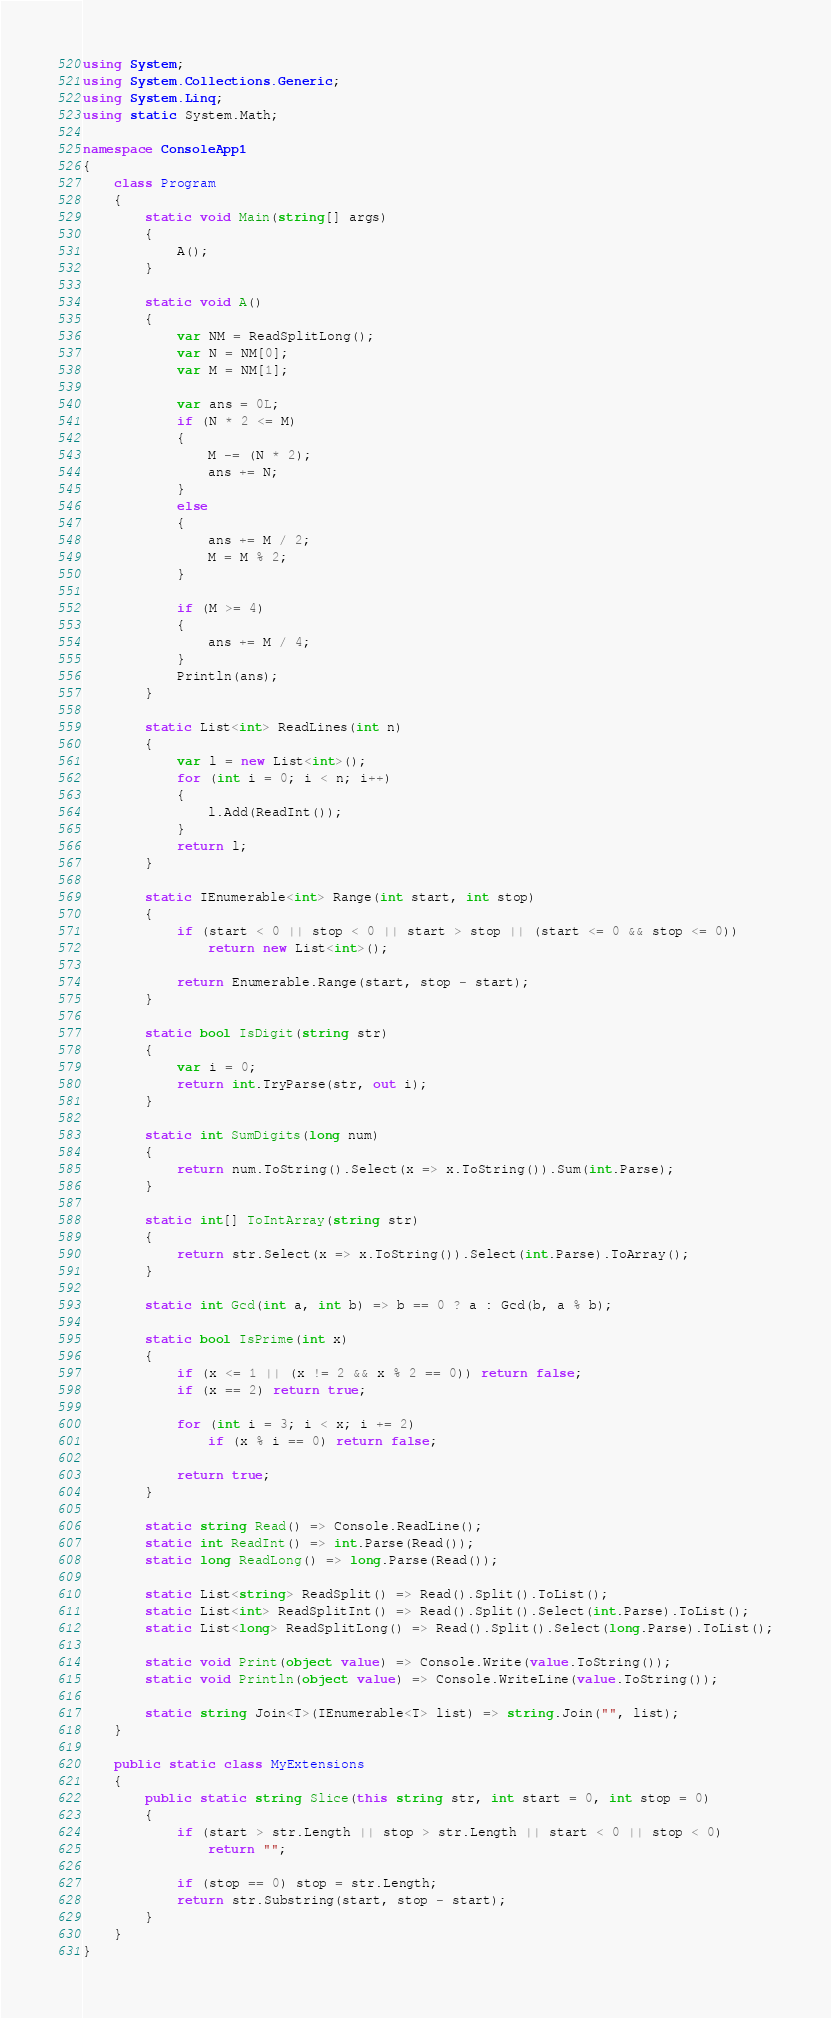Convert code to text. <code><loc_0><loc_0><loc_500><loc_500><_C#_>using System;
using System.Collections.Generic;
using System.Linq;
using static System.Math;

namespace ConsoleApp1
{
    class Program
    {
        static void Main(string[] args)
        {
            A();
        }

        static void A()
        {
            var NM = ReadSplitLong();
            var N = NM[0];
            var M = NM[1];

            var ans = 0L;
            if (N * 2 <= M)
            {
                M -= (N * 2);
                ans += N;
            }
            else
            {
                ans += M / 2;
                M = M % 2;
            }

            if (M >= 4)
            {
                ans += M / 4;
            }
            Println(ans);
        }

        static List<int> ReadLines(int n)
        {
            var l = new List<int>();
            for (int i = 0; i < n; i++)
            {
                l.Add(ReadInt());
            }
            return l;
        }

        static IEnumerable<int> Range(int start, int stop)
        {
            if (start < 0 || stop < 0 || start > stop || (start <= 0 && stop <= 0))
                return new List<int>();

            return Enumerable.Range(start, stop - start);
        }

        static bool IsDigit(string str)
        {
            var i = 0;
            return int.TryParse(str, out i);
        }

        static int SumDigits(long num)
        {
            return num.ToString().Select(x => x.ToString()).Sum(int.Parse);
        }

        static int[] ToIntArray(string str)
        {
            return str.Select(x => x.ToString()).Select(int.Parse).ToArray();
        }

        static int Gcd(int a, int b) => b == 0 ? a : Gcd(b, a % b);

        static bool IsPrime(int x)
        {
            if (x <= 1 || (x != 2 && x % 2 == 0)) return false;
            if (x == 2) return true;

            for (int i = 3; i < x; i += 2)
                if (x % i == 0) return false;

            return true;
        }

        static string Read() => Console.ReadLine();
        static int ReadInt() => int.Parse(Read());
        static long ReadLong() => long.Parse(Read());

        static List<string> ReadSplit() => Read().Split().ToList();
        static List<int> ReadSplitInt() => Read().Split().Select(int.Parse).ToList();
        static List<long> ReadSplitLong() => Read().Split().Select(long.Parse).ToList();

        static void Print(object value) => Console.Write(value.ToString());
        static void Println(object value) => Console.WriteLine(value.ToString());

        static string Join<T>(IEnumerable<T> list) => string.Join("", list);
    }

    public static class MyExtensions
    {
        public static string Slice(this string str, int start = 0, int stop = 0)
        {
            if (start > str.Length || stop > str.Length || start < 0 || stop < 0)
                return "";

            if (stop == 0) stop = str.Length;
            return str.Substring(start, stop - start);
        }
    }
}
</code> 